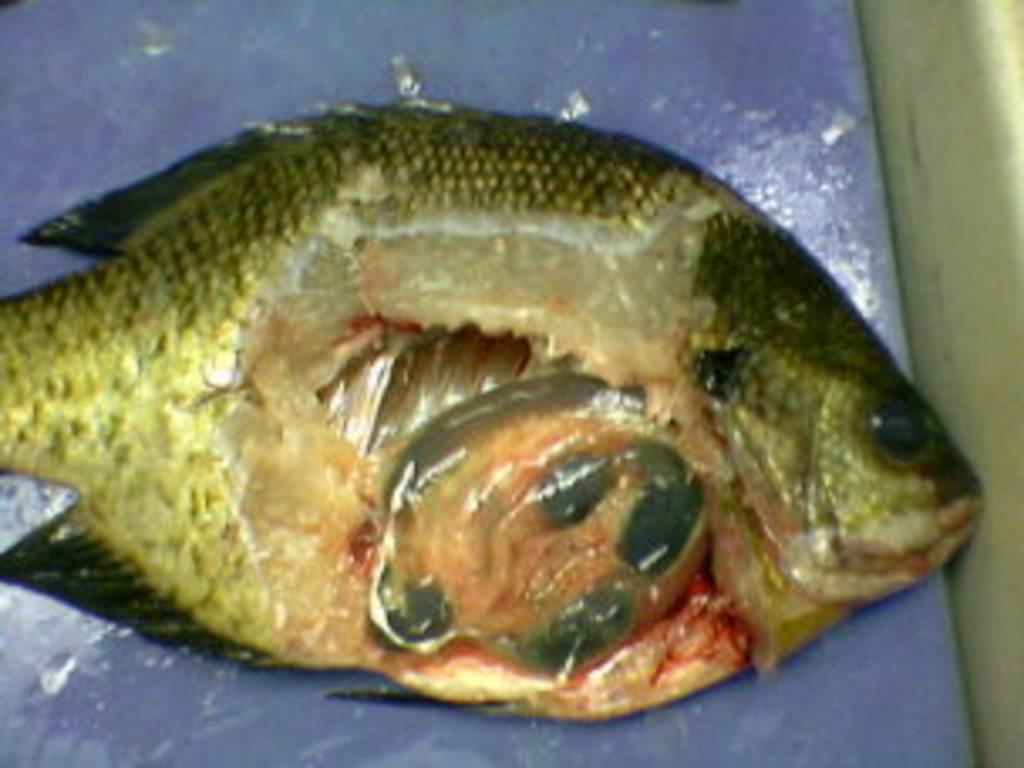Describe this image in one or two sentences. Here we can see fish on surface. 